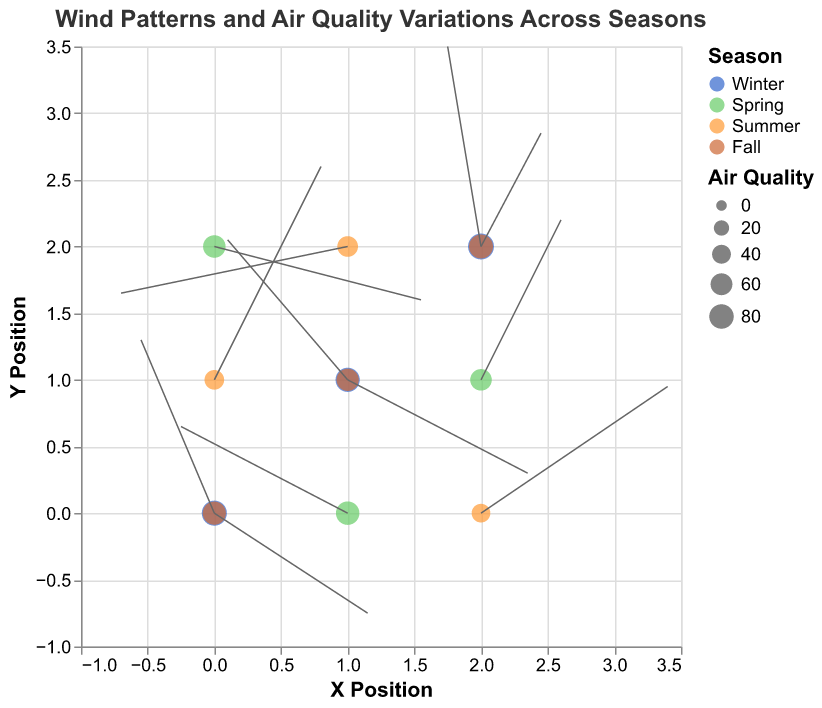what are the x and y-axis titles? The x-axis title is "X Position," and the y-axis title is "Y Position" as indicated in the axis labels of the plot.
Answer: X Position, Y Position How many seasons are represented in the plot? There are four seasons represented in the plot, identified by different colors: Winter (blue), Spring (green), Summer (orange), and Fall (brown).
Answer: 4 Which season has the highest air quality value and what is it? Winter has the highest air quality value of 92, represented by the size of the point at coordinates (2,2) in winter.
Answer: Winter, 92 During which season is the air quality value at (0,1) position? The air quality value at position (0,1) is during Summer, identified by the yellow-orange shade of the point at this position.
Answer: Summer Compare the wind patterns at (1,1) during winter and fall. Which direction and intensity are different? In winter at (1,1), the wind direction is approximately southwest with intensity vectors u=-1.8, v=2.1. In fall at the same location, the direction is southeast with vectors u=2.7, v=-1.4.
Answer: Direction: winter-southwest, fall-southeast; Intensity: winter(-1.8,2.1), fall(2.7,-1.4) Identify which season and location have both negative values for u and v. During summer, at coordinates (1,2), both u and v values are negative with u=-3.4, v=-0.7.
Answer: Summer, (1,2) How does air quality vary with seasons based on the size of points? Air quality generally varies with larger sizes in Winter and Fall indicating higher values, while smaller sizes in Summer and Spring indicate lower air quality values.
Answer: Larger in Winter and Fall, smaller in Summer and Spring Calculate the average air quality during summer at points represented in the plot. Summer air quality values are 45 at (0,1), 52 at (1,2), and 39 at (2,0). The average is (45+52+39)/3 = 45.33.
Answer: 45.33 What direction is the wind blowing at (0,0) during Fall? The wind is blowing north-east at coordinates (0,0) during Fall with vectors u=-1.1, v=2.6.
Answer: North-East 